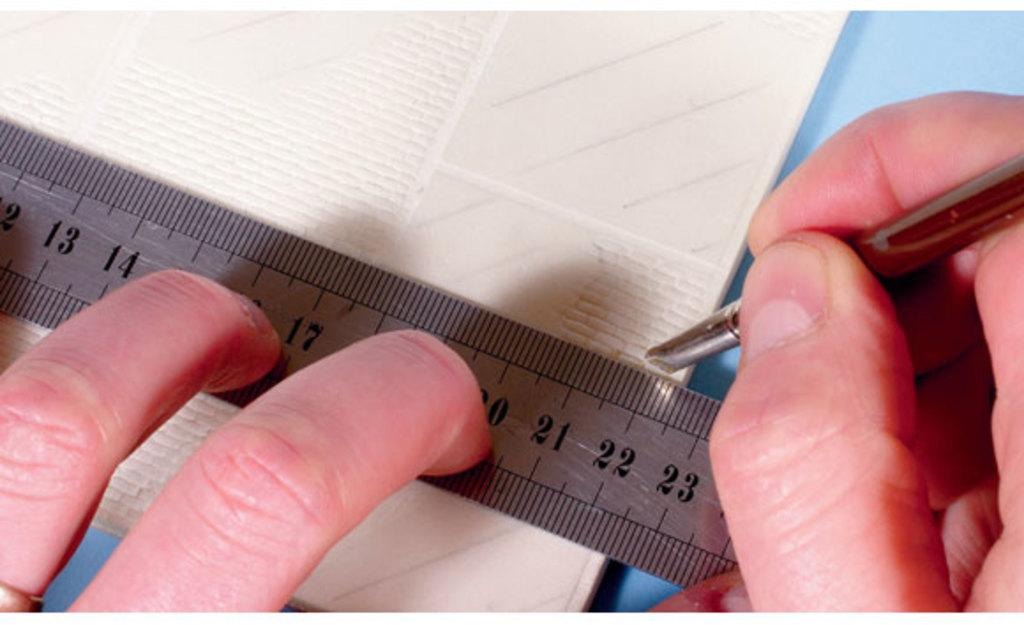<image>
Describe the image concisely. A person is holding a ruler and marking a point at about 22 centimeters. 